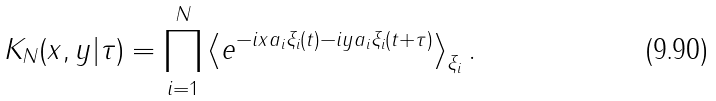Convert formula to latex. <formula><loc_0><loc_0><loc_500><loc_500>K _ { N } ( x , y | \tau ) = \prod _ { i = 1 } ^ { N } \left < e ^ { - i x a _ { i } \xi _ { i } ( t ) - i y a _ { i } \xi _ { i } ( t + \tau ) } \right > _ { \xi _ { i } } .</formula> 